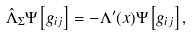<formula> <loc_0><loc_0><loc_500><loc_500>\hat { \Lambda } _ { \Sigma } \Psi \left [ g _ { i j } \right ] = - \Lambda ^ { \prime } ( x ) \Psi \left [ g _ { i j } \right ] ,</formula> 